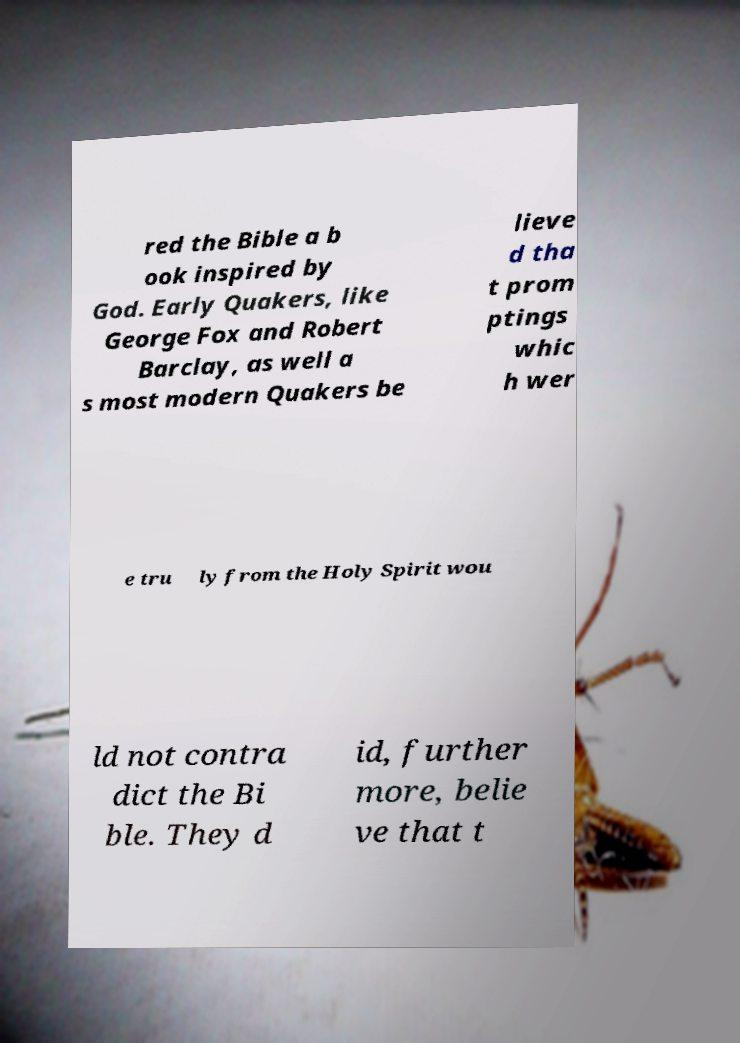Could you extract and type out the text from this image? red the Bible a b ook inspired by God. Early Quakers, like George Fox and Robert Barclay, as well a s most modern Quakers be lieve d tha t prom ptings whic h wer e tru ly from the Holy Spirit wou ld not contra dict the Bi ble. They d id, further more, belie ve that t 